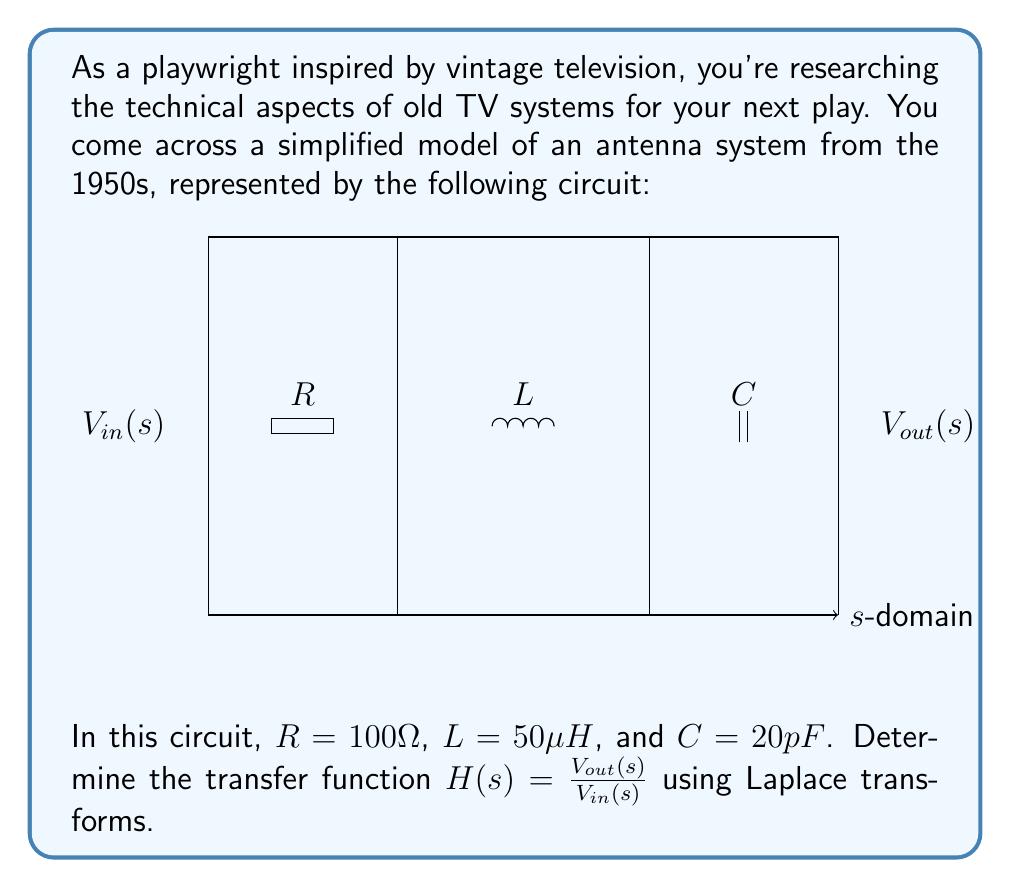Show me your answer to this math problem. Let's approach this step-by-step:

1) In the s-domain, the impedances of the components are:
   $Z_R = R$
   $Z_L = sL$
   $Z_C = \frac{1}{sC}$

2) The total impedance of the circuit is the sum of these impedances:
   $$Z_{total} = R + sL + \frac{1}{sC}$$

3) The transfer function $H(s)$ is the ratio of the output voltage to the input voltage. In this case, it's the voltage across the capacitor divided by the input voltage:

   $$H(s) = \frac{V_{out}(s)}{V_{in}(s)} = \frac{Z_C}{Z_{total}} = \frac{\frac{1}{sC}}{R + sL + \frac{1}{sC}}$$

4) Let's substitute the given values:
   $R = 100 \Omega$
   $L = 50 \mu H = 50 \times 10^{-6} H$
   $C = 20 pF = 20 \times 10^{-12} F$

   $$H(s) = \frac{\frac{1}{20 \times 10^{-12}s}}{100 + 50 \times 10^{-6}s + \frac{1}{20 \times 10^{-12}s}}$$

5) Simplify by multiplying numerator and denominator by $20 \times 10^{-12}s$:

   $$H(s) = \frac{1}{2 \times 10^{-9}s^2 + 100 \times 20 \times 10^{-12}s + 1}$$

6) Further simplify:

   $$H(s) = \frac{1}{2 \times 10^{-9}s^2 + 2 \times 10^{-9}s + 1}$$

This is the transfer function of the antenna system in the Laplace domain.
Answer: $$H(s) = \frac{1}{2 \times 10^{-9}s^2 + 2 \times 10^{-9}s + 1}$$ 